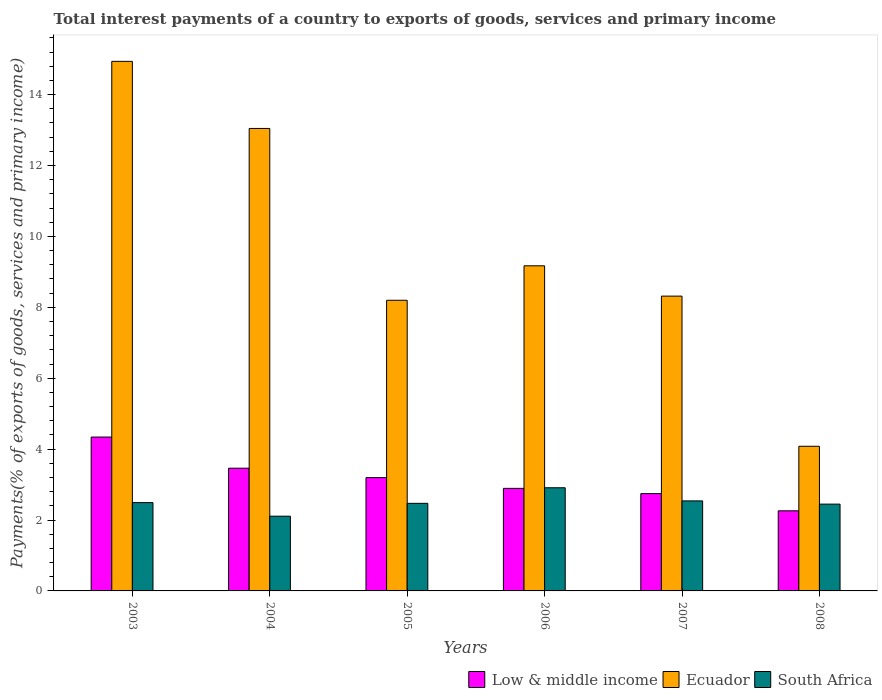How many different coloured bars are there?
Ensure brevity in your answer.  3. Are the number of bars on each tick of the X-axis equal?
Offer a very short reply. Yes. How many bars are there on the 4th tick from the left?
Your answer should be very brief. 3. What is the total interest payments in Ecuador in 2006?
Provide a short and direct response. 9.17. Across all years, what is the maximum total interest payments in Low & middle income?
Your answer should be compact. 4.34. Across all years, what is the minimum total interest payments in Low & middle income?
Offer a terse response. 2.26. What is the total total interest payments in Low & middle income in the graph?
Keep it short and to the point. 18.89. What is the difference between the total interest payments in Ecuador in 2003 and that in 2008?
Offer a very short reply. 10.86. What is the difference between the total interest payments in Low & middle income in 2005 and the total interest payments in Ecuador in 2003?
Offer a very short reply. -11.74. What is the average total interest payments in South Africa per year?
Make the answer very short. 2.49. In the year 2004, what is the difference between the total interest payments in Low & middle income and total interest payments in Ecuador?
Give a very brief answer. -9.58. In how many years, is the total interest payments in Ecuador greater than 10.4 %?
Provide a succinct answer. 2. What is the ratio of the total interest payments in Ecuador in 2004 to that in 2005?
Offer a very short reply. 1.59. Is the total interest payments in Ecuador in 2004 less than that in 2007?
Offer a very short reply. No. What is the difference between the highest and the second highest total interest payments in Ecuador?
Your answer should be compact. 1.89. What is the difference between the highest and the lowest total interest payments in South Africa?
Provide a short and direct response. 0.8. What does the 3rd bar from the right in 2006 represents?
Provide a short and direct response. Low & middle income. Is it the case that in every year, the sum of the total interest payments in South Africa and total interest payments in Ecuador is greater than the total interest payments in Low & middle income?
Your response must be concise. Yes. How many bars are there?
Make the answer very short. 18. Does the graph contain grids?
Make the answer very short. No. Where does the legend appear in the graph?
Your answer should be compact. Bottom right. What is the title of the graph?
Keep it short and to the point. Total interest payments of a country to exports of goods, services and primary income. What is the label or title of the X-axis?
Make the answer very short. Years. What is the label or title of the Y-axis?
Make the answer very short. Payments(% of exports of goods, services and primary income). What is the Payments(% of exports of goods, services and primary income) of Low & middle income in 2003?
Give a very brief answer. 4.34. What is the Payments(% of exports of goods, services and primary income) in Ecuador in 2003?
Offer a terse response. 14.94. What is the Payments(% of exports of goods, services and primary income) of South Africa in 2003?
Give a very brief answer. 2.49. What is the Payments(% of exports of goods, services and primary income) of Low & middle income in 2004?
Offer a very short reply. 3.46. What is the Payments(% of exports of goods, services and primary income) of Ecuador in 2004?
Your answer should be compact. 13.04. What is the Payments(% of exports of goods, services and primary income) in South Africa in 2004?
Your answer should be very brief. 2.11. What is the Payments(% of exports of goods, services and primary income) of Low & middle income in 2005?
Keep it short and to the point. 3.2. What is the Payments(% of exports of goods, services and primary income) in Ecuador in 2005?
Provide a succinct answer. 8.2. What is the Payments(% of exports of goods, services and primary income) of South Africa in 2005?
Offer a very short reply. 2.47. What is the Payments(% of exports of goods, services and primary income) in Low & middle income in 2006?
Offer a terse response. 2.89. What is the Payments(% of exports of goods, services and primary income) of Ecuador in 2006?
Provide a succinct answer. 9.17. What is the Payments(% of exports of goods, services and primary income) of South Africa in 2006?
Ensure brevity in your answer.  2.91. What is the Payments(% of exports of goods, services and primary income) of Low & middle income in 2007?
Give a very brief answer. 2.75. What is the Payments(% of exports of goods, services and primary income) of Ecuador in 2007?
Keep it short and to the point. 8.32. What is the Payments(% of exports of goods, services and primary income) in South Africa in 2007?
Keep it short and to the point. 2.54. What is the Payments(% of exports of goods, services and primary income) of Low & middle income in 2008?
Your response must be concise. 2.26. What is the Payments(% of exports of goods, services and primary income) in Ecuador in 2008?
Make the answer very short. 4.08. What is the Payments(% of exports of goods, services and primary income) in South Africa in 2008?
Offer a very short reply. 2.45. Across all years, what is the maximum Payments(% of exports of goods, services and primary income) of Low & middle income?
Provide a short and direct response. 4.34. Across all years, what is the maximum Payments(% of exports of goods, services and primary income) of Ecuador?
Your answer should be very brief. 14.94. Across all years, what is the maximum Payments(% of exports of goods, services and primary income) in South Africa?
Ensure brevity in your answer.  2.91. Across all years, what is the minimum Payments(% of exports of goods, services and primary income) in Low & middle income?
Give a very brief answer. 2.26. Across all years, what is the minimum Payments(% of exports of goods, services and primary income) in Ecuador?
Provide a succinct answer. 4.08. Across all years, what is the minimum Payments(% of exports of goods, services and primary income) of South Africa?
Provide a short and direct response. 2.11. What is the total Payments(% of exports of goods, services and primary income) in Low & middle income in the graph?
Provide a succinct answer. 18.89. What is the total Payments(% of exports of goods, services and primary income) in Ecuador in the graph?
Offer a terse response. 57.74. What is the total Payments(% of exports of goods, services and primary income) of South Africa in the graph?
Your response must be concise. 14.97. What is the difference between the Payments(% of exports of goods, services and primary income) in Low & middle income in 2003 and that in 2004?
Make the answer very short. 0.88. What is the difference between the Payments(% of exports of goods, services and primary income) in Ecuador in 2003 and that in 2004?
Offer a very short reply. 1.89. What is the difference between the Payments(% of exports of goods, services and primary income) of South Africa in 2003 and that in 2004?
Offer a very short reply. 0.38. What is the difference between the Payments(% of exports of goods, services and primary income) in Low & middle income in 2003 and that in 2005?
Make the answer very short. 1.14. What is the difference between the Payments(% of exports of goods, services and primary income) in Ecuador in 2003 and that in 2005?
Offer a terse response. 6.74. What is the difference between the Payments(% of exports of goods, services and primary income) of South Africa in 2003 and that in 2005?
Ensure brevity in your answer.  0.02. What is the difference between the Payments(% of exports of goods, services and primary income) of Low & middle income in 2003 and that in 2006?
Provide a succinct answer. 1.45. What is the difference between the Payments(% of exports of goods, services and primary income) in Ecuador in 2003 and that in 2006?
Make the answer very short. 5.77. What is the difference between the Payments(% of exports of goods, services and primary income) in South Africa in 2003 and that in 2006?
Provide a short and direct response. -0.42. What is the difference between the Payments(% of exports of goods, services and primary income) in Low & middle income in 2003 and that in 2007?
Offer a very short reply. 1.59. What is the difference between the Payments(% of exports of goods, services and primary income) in Ecuador in 2003 and that in 2007?
Keep it short and to the point. 6.62. What is the difference between the Payments(% of exports of goods, services and primary income) of South Africa in 2003 and that in 2007?
Offer a terse response. -0.05. What is the difference between the Payments(% of exports of goods, services and primary income) in Low & middle income in 2003 and that in 2008?
Ensure brevity in your answer.  2.08. What is the difference between the Payments(% of exports of goods, services and primary income) in Ecuador in 2003 and that in 2008?
Your answer should be very brief. 10.86. What is the difference between the Payments(% of exports of goods, services and primary income) in South Africa in 2003 and that in 2008?
Give a very brief answer. 0.04. What is the difference between the Payments(% of exports of goods, services and primary income) of Low & middle income in 2004 and that in 2005?
Provide a succinct answer. 0.27. What is the difference between the Payments(% of exports of goods, services and primary income) of Ecuador in 2004 and that in 2005?
Your response must be concise. 4.85. What is the difference between the Payments(% of exports of goods, services and primary income) in South Africa in 2004 and that in 2005?
Make the answer very short. -0.36. What is the difference between the Payments(% of exports of goods, services and primary income) of Low & middle income in 2004 and that in 2006?
Your answer should be very brief. 0.57. What is the difference between the Payments(% of exports of goods, services and primary income) in Ecuador in 2004 and that in 2006?
Offer a very short reply. 3.87. What is the difference between the Payments(% of exports of goods, services and primary income) in South Africa in 2004 and that in 2006?
Your answer should be compact. -0.8. What is the difference between the Payments(% of exports of goods, services and primary income) of Low & middle income in 2004 and that in 2007?
Provide a short and direct response. 0.72. What is the difference between the Payments(% of exports of goods, services and primary income) of Ecuador in 2004 and that in 2007?
Ensure brevity in your answer.  4.73. What is the difference between the Payments(% of exports of goods, services and primary income) of South Africa in 2004 and that in 2007?
Your answer should be compact. -0.43. What is the difference between the Payments(% of exports of goods, services and primary income) of Low & middle income in 2004 and that in 2008?
Your answer should be compact. 1.2. What is the difference between the Payments(% of exports of goods, services and primary income) in Ecuador in 2004 and that in 2008?
Keep it short and to the point. 8.96. What is the difference between the Payments(% of exports of goods, services and primary income) in South Africa in 2004 and that in 2008?
Keep it short and to the point. -0.34. What is the difference between the Payments(% of exports of goods, services and primary income) in Low & middle income in 2005 and that in 2006?
Your answer should be compact. 0.3. What is the difference between the Payments(% of exports of goods, services and primary income) of Ecuador in 2005 and that in 2006?
Your answer should be compact. -0.97. What is the difference between the Payments(% of exports of goods, services and primary income) in South Africa in 2005 and that in 2006?
Your answer should be very brief. -0.44. What is the difference between the Payments(% of exports of goods, services and primary income) in Low & middle income in 2005 and that in 2007?
Your answer should be very brief. 0.45. What is the difference between the Payments(% of exports of goods, services and primary income) in Ecuador in 2005 and that in 2007?
Your answer should be compact. -0.12. What is the difference between the Payments(% of exports of goods, services and primary income) in South Africa in 2005 and that in 2007?
Offer a terse response. -0.07. What is the difference between the Payments(% of exports of goods, services and primary income) of Low & middle income in 2005 and that in 2008?
Make the answer very short. 0.94. What is the difference between the Payments(% of exports of goods, services and primary income) of Ecuador in 2005 and that in 2008?
Keep it short and to the point. 4.12. What is the difference between the Payments(% of exports of goods, services and primary income) of South Africa in 2005 and that in 2008?
Your answer should be very brief. 0.02. What is the difference between the Payments(% of exports of goods, services and primary income) in Low & middle income in 2006 and that in 2007?
Make the answer very short. 0.15. What is the difference between the Payments(% of exports of goods, services and primary income) in Ecuador in 2006 and that in 2007?
Give a very brief answer. 0.85. What is the difference between the Payments(% of exports of goods, services and primary income) of South Africa in 2006 and that in 2007?
Keep it short and to the point. 0.37. What is the difference between the Payments(% of exports of goods, services and primary income) in Low & middle income in 2006 and that in 2008?
Your response must be concise. 0.63. What is the difference between the Payments(% of exports of goods, services and primary income) of Ecuador in 2006 and that in 2008?
Provide a short and direct response. 5.09. What is the difference between the Payments(% of exports of goods, services and primary income) of South Africa in 2006 and that in 2008?
Your answer should be compact. 0.46. What is the difference between the Payments(% of exports of goods, services and primary income) in Low & middle income in 2007 and that in 2008?
Your answer should be compact. 0.49. What is the difference between the Payments(% of exports of goods, services and primary income) in Ecuador in 2007 and that in 2008?
Keep it short and to the point. 4.24. What is the difference between the Payments(% of exports of goods, services and primary income) in South Africa in 2007 and that in 2008?
Keep it short and to the point. 0.09. What is the difference between the Payments(% of exports of goods, services and primary income) of Low & middle income in 2003 and the Payments(% of exports of goods, services and primary income) of Ecuador in 2004?
Make the answer very short. -8.7. What is the difference between the Payments(% of exports of goods, services and primary income) of Low & middle income in 2003 and the Payments(% of exports of goods, services and primary income) of South Africa in 2004?
Offer a very short reply. 2.23. What is the difference between the Payments(% of exports of goods, services and primary income) in Ecuador in 2003 and the Payments(% of exports of goods, services and primary income) in South Africa in 2004?
Provide a short and direct response. 12.83. What is the difference between the Payments(% of exports of goods, services and primary income) of Low & middle income in 2003 and the Payments(% of exports of goods, services and primary income) of Ecuador in 2005?
Offer a terse response. -3.86. What is the difference between the Payments(% of exports of goods, services and primary income) of Low & middle income in 2003 and the Payments(% of exports of goods, services and primary income) of South Africa in 2005?
Make the answer very short. 1.87. What is the difference between the Payments(% of exports of goods, services and primary income) of Ecuador in 2003 and the Payments(% of exports of goods, services and primary income) of South Africa in 2005?
Keep it short and to the point. 12.47. What is the difference between the Payments(% of exports of goods, services and primary income) in Low & middle income in 2003 and the Payments(% of exports of goods, services and primary income) in Ecuador in 2006?
Your response must be concise. -4.83. What is the difference between the Payments(% of exports of goods, services and primary income) of Low & middle income in 2003 and the Payments(% of exports of goods, services and primary income) of South Africa in 2006?
Give a very brief answer. 1.43. What is the difference between the Payments(% of exports of goods, services and primary income) of Ecuador in 2003 and the Payments(% of exports of goods, services and primary income) of South Africa in 2006?
Keep it short and to the point. 12.03. What is the difference between the Payments(% of exports of goods, services and primary income) of Low & middle income in 2003 and the Payments(% of exports of goods, services and primary income) of Ecuador in 2007?
Your answer should be compact. -3.98. What is the difference between the Payments(% of exports of goods, services and primary income) of Low & middle income in 2003 and the Payments(% of exports of goods, services and primary income) of South Africa in 2007?
Your response must be concise. 1.8. What is the difference between the Payments(% of exports of goods, services and primary income) of Ecuador in 2003 and the Payments(% of exports of goods, services and primary income) of South Africa in 2007?
Provide a succinct answer. 12.4. What is the difference between the Payments(% of exports of goods, services and primary income) in Low & middle income in 2003 and the Payments(% of exports of goods, services and primary income) in Ecuador in 2008?
Make the answer very short. 0.26. What is the difference between the Payments(% of exports of goods, services and primary income) in Low & middle income in 2003 and the Payments(% of exports of goods, services and primary income) in South Africa in 2008?
Your answer should be compact. 1.89. What is the difference between the Payments(% of exports of goods, services and primary income) in Ecuador in 2003 and the Payments(% of exports of goods, services and primary income) in South Africa in 2008?
Keep it short and to the point. 12.49. What is the difference between the Payments(% of exports of goods, services and primary income) of Low & middle income in 2004 and the Payments(% of exports of goods, services and primary income) of Ecuador in 2005?
Your response must be concise. -4.74. What is the difference between the Payments(% of exports of goods, services and primary income) in Low & middle income in 2004 and the Payments(% of exports of goods, services and primary income) in South Africa in 2005?
Provide a succinct answer. 0.99. What is the difference between the Payments(% of exports of goods, services and primary income) of Ecuador in 2004 and the Payments(% of exports of goods, services and primary income) of South Africa in 2005?
Ensure brevity in your answer.  10.57. What is the difference between the Payments(% of exports of goods, services and primary income) of Low & middle income in 2004 and the Payments(% of exports of goods, services and primary income) of Ecuador in 2006?
Give a very brief answer. -5.71. What is the difference between the Payments(% of exports of goods, services and primary income) of Low & middle income in 2004 and the Payments(% of exports of goods, services and primary income) of South Africa in 2006?
Offer a terse response. 0.55. What is the difference between the Payments(% of exports of goods, services and primary income) of Ecuador in 2004 and the Payments(% of exports of goods, services and primary income) of South Africa in 2006?
Make the answer very short. 10.13. What is the difference between the Payments(% of exports of goods, services and primary income) in Low & middle income in 2004 and the Payments(% of exports of goods, services and primary income) in Ecuador in 2007?
Offer a very short reply. -4.85. What is the difference between the Payments(% of exports of goods, services and primary income) of Low & middle income in 2004 and the Payments(% of exports of goods, services and primary income) of South Africa in 2007?
Give a very brief answer. 0.92. What is the difference between the Payments(% of exports of goods, services and primary income) of Ecuador in 2004 and the Payments(% of exports of goods, services and primary income) of South Africa in 2007?
Provide a short and direct response. 10.5. What is the difference between the Payments(% of exports of goods, services and primary income) in Low & middle income in 2004 and the Payments(% of exports of goods, services and primary income) in Ecuador in 2008?
Provide a short and direct response. -0.62. What is the difference between the Payments(% of exports of goods, services and primary income) of Low & middle income in 2004 and the Payments(% of exports of goods, services and primary income) of South Africa in 2008?
Provide a short and direct response. 1.01. What is the difference between the Payments(% of exports of goods, services and primary income) of Ecuador in 2004 and the Payments(% of exports of goods, services and primary income) of South Africa in 2008?
Provide a short and direct response. 10.6. What is the difference between the Payments(% of exports of goods, services and primary income) in Low & middle income in 2005 and the Payments(% of exports of goods, services and primary income) in Ecuador in 2006?
Provide a succinct answer. -5.97. What is the difference between the Payments(% of exports of goods, services and primary income) of Low & middle income in 2005 and the Payments(% of exports of goods, services and primary income) of South Africa in 2006?
Your answer should be compact. 0.29. What is the difference between the Payments(% of exports of goods, services and primary income) in Ecuador in 2005 and the Payments(% of exports of goods, services and primary income) in South Africa in 2006?
Provide a succinct answer. 5.29. What is the difference between the Payments(% of exports of goods, services and primary income) in Low & middle income in 2005 and the Payments(% of exports of goods, services and primary income) in Ecuador in 2007?
Your response must be concise. -5.12. What is the difference between the Payments(% of exports of goods, services and primary income) of Low & middle income in 2005 and the Payments(% of exports of goods, services and primary income) of South Africa in 2007?
Your answer should be very brief. 0.66. What is the difference between the Payments(% of exports of goods, services and primary income) of Ecuador in 2005 and the Payments(% of exports of goods, services and primary income) of South Africa in 2007?
Make the answer very short. 5.66. What is the difference between the Payments(% of exports of goods, services and primary income) in Low & middle income in 2005 and the Payments(% of exports of goods, services and primary income) in Ecuador in 2008?
Your answer should be compact. -0.88. What is the difference between the Payments(% of exports of goods, services and primary income) in Low & middle income in 2005 and the Payments(% of exports of goods, services and primary income) in South Africa in 2008?
Make the answer very short. 0.75. What is the difference between the Payments(% of exports of goods, services and primary income) of Ecuador in 2005 and the Payments(% of exports of goods, services and primary income) of South Africa in 2008?
Your answer should be compact. 5.75. What is the difference between the Payments(% of exports of goods, services and primary income) of Low & middle income in 2006 and the Payments(% of exports of goods, services and primary income) of Ecuador in 2007?
Offer a terse response. -5.42. What is the difference between the Payments(% of exports of goods, services and primary income) of Low & middle income in 2006 and the Payments(% of exports of goods, services and primary income) of South Africa in 2007?
Your answer should be very brief. 0.35. What is the difference between the Payments(% of exports of goods, services and primary income) in Ecuador in 2006 and the Payments(% of exports of goods, services and primary income) in South Africa in 2007?
Make the answer very short. 6.63. What is the difference between the Payments(% of exports of goods, services and primary income) in Low & middle income in 2006 and the Payments(% of exports of goods, services and primary income) in Ecuador in 2008?
Make the answer very short. -1.19. What is the difference between the Payments(% of exports of goods, services and primary income) in Low & middle income in 2006 and the Payments(% of exports of goods, services and primary income) in South Africa in 2008?
Provide a short and direct response. 0.44. What is the difference between the Payments(% of exports of goods, services and primary income) of Ecuador in 2006 and the Payments(% of exports of goods, services and primary income) of South Africa in 2008?
Offer a terse response. 6.72. What is the difference between the Payments(% of exports of goods, services and primary income) of Low & middle income in 2007 and the Payments(% of exports of goods, services and primary income) of Ecuador in 2008?
Give a very brief answer. -1.33. What is the difference between the Payments(% of exports of goods, services and primary income) of Low & middle income in 2007 and the Payments(% of exports of goods, services and primary income) of South Africa in 2008?
Offer a terse response. 0.3. What is the difference between the Payments(% of exports of goods, services and primary income) of Ecuador in 2007 and the Payments(% of exports of goods, services and primary income) of South Africa in 2008?
Provide a short and direct response. 5.87. What is the average Payments(% of exports of goods, services and primary income) in Low & middle income per year?
Provide a succinct answer. 3.15. What is the average Payments(% of exports of goods, services and primary income) in Ecuador per year?
Give a very brief answer. 9.62. What is the average Payments(% of exports of goods, services and primary income) of South Africa per year?
Your answer should be very brief. 2.49. In the year 2003, what is the difference between the Payments(% of exports of goods, services and primary income) of Low & middle income and Payments(% of exports of goods, services and primary income) of Ecuador?
Provide a short and direct response. -10.6. In the year 2003, what is the difference between the Payments(% of exports of goods, services and primary income) of Low & middle income and Payments(% of exports of goods, services and primary income) of South Africa?
Your answer should be very brief. 1.85. In the year 2003, what is the difference between the Payments(% of exports of goods, services and primary income) in Ecuador and Payments(% of exports of goods, services and primary income) in South Africa?
Give a very brief answer. 12.45. In the year 2004, what is the difference between the Payments(% of exports of goods, services and primary income) in Low & middle income and Payments(% of exports of goods, services and primary income) in Ecuador?
Your answer should be compact. -9.58. In the year 2004, what is the difference between the Payments(% of exports of goods, services and primary income) of Low & middle income and Payments(% of exports of goods, services and primary income) of South Africa?
Give a very brief answer. 1.35. In the year 2004, what is the difference between the Payments(% of exports of goods, services and primary income) of Ecuador and Payments(% of exports of goods, services and primary income) of South Africa?
Offer a very short reply. 10.94. In the year 2005, what is the difference between the Payments(% of exports of goods, services and primary income) of Low & middle income and Payments(% of exports of goods, services and primary income) of Ecuador?
Provide a short and direct response. -5. In the year 2005, what is the difference between the Payments(% of exports of goods, services and primary income) in Low & middle income and Payments(% of exports of goods, services and primary income) in South Africa?
Offer a terse response. 0.73. In the year 2005, what is the difference between the Payments(% of exports of goods, services and primary income) of Ecuador and Payments(% of exports of goods, services and primary income) of South Africa?
Your answer should be compact. 5.73. In the year 2006, what is the difference between the Payments(% of exports of goods, services and primary income) of Low & middle income and Payments(% of exports of goods, services and primary income) of Ecuador?
Give a very brief answer. -6.28. In the year 2006, what is the difference between the Payments(% of exports of goods, services and primary income) in Low & middle income and Payments(% of exports of goods, services and primary income) in South Africa?
Your response must be concise. -0.02. In the year 2006, what is the difference between the Payments(% of exports of goods, services and primary income) in Ecuador and Payments(% of exports of goods, services and primary income) in South Africa?
Provide a succinct answer. 6.26. In the year 2007, what is the difference between the Payments(% of exports of goods, services and primary income) of Low & middle income and Payments(% of exports of goods, services and primary income) of Ecuador?
Offer a very short reply. -5.57. In the year 2007, what is the difference between the Payments(% of exports of goods, services and primary income) in Low & middle income and Payments(% of exports of goods, services and primary income) in South Africa?
Your answer should be compact. 0.21. In the year 2007, what is the difference between the Payments(% of exports of goods, services and primary income) in Ecuador and Payments(% of exports of goods, services and primary income) in South Africa?
Keep it short and to the point. 5.78. In the year 2008, what is the difference between the Payments(% of exports of goods, services and primary income) of Low & middle income and Payments(% of exports of goods, services and primary income) of Ecuador?
Offer a very short reply. -1.82. In the year 2008, what is the difference between the Payments(% of exports of goods, services and primary income) in Low & middle income and Payments(% of exports of goods, services and primary income) in South Africa?
Your response must be concise. -0.19. In the year 2008, what is the difference between the Payments(% of exports of goods, services and primary income) in Ecuador and Payments(% of exports of goods, services and primary income) in South Africa?
Your answer should be compact. 1.63. What is the ratio of the Payments(% of exports of goods, services and primary income) of Low & middle income in 2003 to that in 2004?
Your answer should be compact. 1.25. What is the ratio of the Payments(% of exports of goods, services and primary income) in Ecuador in 2003 to that in 2004?
Ensure brevity in your answer.  1.15. What is the ratio of the Payments(% of exports of goods, services and primary income) in South Africa in 2003 to that in 2004?
Your response must be concise. 1.18. What is the ratio of the Payments(% of exports of goods, services and primary income) of Low & middle income in 2003 to that in 2005?
Your answer should be compact. 1.36. What is the ratio of the Payments(% of exports of goods, services and primary income) of Ecuador in 2003 to that in 2005?
Your response must be concise. 1.82. What is the ratio of the Payments(% of exports of goods, services and primary income) in South Africa in 2003 to that in 2005?
Make the answer very short. 1.01. What is the ratio of the Payments(% of exports of goods, services and primary income) of Low & middle income in 2003 to that in 2006?
Your answer should be compact. 1.5. What is the ratio of the Payments(% of exports of goods, services and primary income) in Ecuador in 2003 to that in 2006?
Make the answer very short. 1.63. What is the ratio of the Payments(% of exports of goods, services and primary income) in South Africa in 2003 to that in 2006?
Your answer should be compact. 0.86. What is the ratio of the Payments(% of exports of goods, services and primary income) in Low & middle income in 2003 to that in 2007?
Ensure brevity in your answer.  1.58. What is the ratio of the Payments(% of exports of goods, services and primary income) of Ecuador in 2003 to that in 2007?
Give a very brief answer. 1.8. What is the ratio of the Payments(% of exports of goods, services and primary income) of South Africa in 2003 to that in 2007?
Ensure brevity in your answer.  0.98. What is the ratio of the Payments(% of exports of goods, services and primary income) of Low & middle income in 2003 to that in 2008?
Make the answer very short. 1.92. What is the ratio of the Payments(% of exports of goods, services and primary income) in Ecuador in 2003 to that in 2008?
Ensure brevity in your answer.  3.66. What is the ratio of the Payments(% of exports of goods, services and primary income) in South Africa in 2003 to that in 2008?
Offer a terse response. 1.02. What is the ratio of the Payments(% of exports of goods, services and primary income) in Low & middle income in 2004 to that in 2005?
Keep it short and to the point. 1.08. What is the ratio of the Payments(% of exports of goods, services and primary income) in Ecuador in 2004 to that in 2005?
Offer a terse response. 1.59. What is the ratio of the Payments(% of exports of goods, services and primary income) in South Africa in 2004 to that in 2005?
Offer a terse response. 0.85. What is the ratio of the Payments(% of exports of goods, services and primary income) in Low & middle income in 2004 to that in 2006?
Keep it short and to the point. 1.2. What is the ratio of the Payments(% of exports of goods, services and primary income) of Ecuador in 2004 to that in 2006?
Your response must be concise. 1.42. What is the ratio of the Payments(% of exports of goods, services and primary income) in South Africa in 2004 to that in 2006?
Provide a short and direct response. 0.72. What is the ratio of the Payments(% of exports of goods, services and primary income) in Low & middle income in 2004 to that in 2007?
Your response must be concise. 1.26. What is the ratio of the Payments(% of exports of goods, services and primary income) in Ecuador in 2004 to that in 2007?
Ensure brevity in your answer.  1.57. What is the ratio of the Payments(% of exports of goods, services and primary income) of South Africa in 2004 to that in 2007?
Give a very brief answer. 0.83. What is the ratio of the Payments(% of exports of goods, services and primary income) in Low & middle income in 2004 to that in 2008?
Keep it short and to the point. 1.53. What is the ratio of the Payments(% of exports of goods, services and primary income) of Ecuador in 2004 to that in 2008?
Give a very brief answer. 3.2. What is the ratio of the Payments(% of exports of goods, services and primary income) of South Africa in 2004 to that in 2008?
Provide a succinct answer. 0.86. What is the ratio of the Payments(% of exports of goods, services and primary income) in Low & middle income in 2005 to that in 2006?
Keep it short and to the point. 1.1. What is the ratio of the Payments(% of exports of goods, services and primary income) in Ecuador in 2005 to that in 2006?
Give a very brief answer. 0.89. What is the ratio of the Payments(% of exports of goods, services and primary income) of South Africa in 2005 to that in 2006?
Your answer should be compact. 0.85. What is the ratio of the Payments(% of exports of goods, services and primary income) in Low & middle income in 2005 to that in 2007?
Provide a succinct answer. 1.16. What is the ratio of the Payments(% of exports of goods, services and primary income) in Ecuador in 2005 to that in 2007?
Your answer should be compact. 0.99. What is the ratio of the Payments(% of exports of goods, services and primary income) in South Africa in 2005 to that in 2007?
Your answer should be compact. 0.97. What is the ratio of the Payments(% of exports of goods, services and primary income) in Low & middle income in 2005 to that in 2008?
Ensure brevity in your answer.  1.41. What is the ratio of the Payments(% of exports of goods, services and primary income) in Ecuador in 2005 to that in 2008?
Provide a short and direct response. 2.01. What is the ratio of the Payments(% of exports of goods, services and primary income) of Low & middle income in 2006 to that in 2007?
Give a very brief answer. 1.05. What is the ratio of the Payments(% of exports of goods, services and primary income) of Ecuador in 2006 to that in 2007?
Offer a terse response. 1.1. What is the ratio of the Payments(% of exports of goods, services and primary income) in South Africa in 2006 to that in 2007?
Provide a short and direct response. 1.15. What is the ratio of the Payments(% of exports of goods, services and primary income) of Low & middle income in 2006 to that in 2008?
Your answer should be very brief. 1.28. What is the ratio of the Payments(% of exports of goods, services and primary income) of Ecuador in 2006 to that in 2008?
Your response must be concise. 2.25. What is the ratio of the Payments(% of exports of goods, services and primary income) of South Africa in 2006 to that in 2008?
Your response must be concise. 1.19. What is the ratio of the Payments(% of exports of goods, services and primary income) in Low & middle income in 2007 to that in 2008?
Keep it short and to the point. 1.22. What is the ratio of the Payments(% of exports of goods, services and primary income) of Ecuador in 2007 to that in 2008?
Ensure brevity in your answer.  2.04. What is the ratio of the Payments(% of exports of goods, services and primary income) of South Africa in 2007 to that in 2008?
Your response must be concise. 1.04. What is the difference between the highest and the second highest Payments(% of exports of goods, services and primary income) of Low & middle income?
Your answer should be compact. 0.88. What is the difference between the highest and the second highest Payments(% of exports of goods, services and primary income) in Ecuador?
Give a very brief answer. 1.89. What is the difference between the highest and the second highest Payments(% of exports of goods, services and primary income) of South Africa?
Your response must be concise. 0.37. What is the difference between the highest and the lowest Payments(% of exports of goods, services and primary income) of Low & middle income?
Your answer should be compact. 2.08. What is the difference between the highest and the lowest Payments(% of exports of goods, services and primary income) of Ecuador?
Provide a succinct answer. 10.86. What is the difference between the highest and the lowest Payments(% of exports of goods, services and primary income) in South Africa?
Your answer should be very brief. 0.8. 